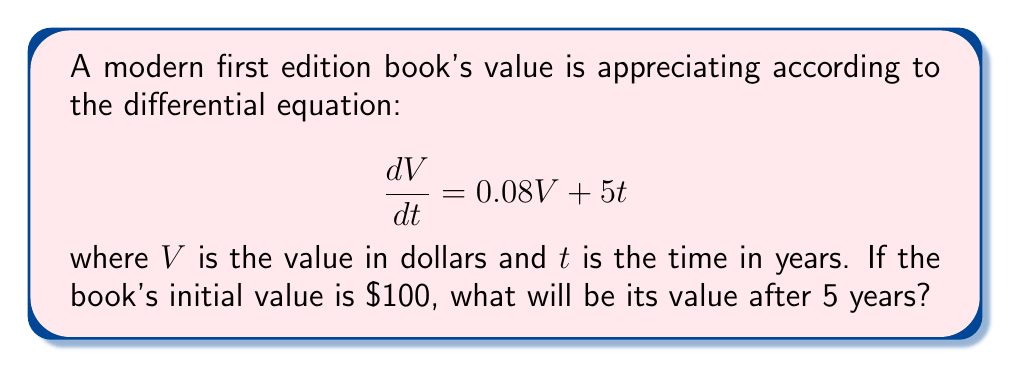Solve this math problem. To solve this first-order linear differential equation, we'll use the integrating factor method:

1) The equation is in the form $\frac{dV}{dt} + P(t)V = Q(t)$ where $P(t) = -0.08$ and $Q(t) = 5t$.

2) The integrating factor is $\mu(t) = e^{\int P(t) dt} = e^{-0.08t}$.

3) Multiply both sides of the equation by $\mu(t)$:

   $e^{-0.08t}\frac{dV}{dt} + 0.08e^{-0.08t}V = 5te^{-0.08t}$

4) The left side is now the derivative of $e^{-0.08t}V$. Rewrite the equation:

   $\frac{d}{dt}(e^{-0.08t}V) = 5te^{-0.08t}$

5) Integrate both sides:

   $e^{-0.08t}V = \int 5te^{-0.08t}dt$

6) Solve the integral on the right side using integration by parts:

   $e^{-0.08t}V = -62.5te^{-0.08t} - 781.25e^{-0.08t} + C$

7) Solve for $V$:

   $V = -62.5t - 781.25 + Ce^{0.08t}$

8) Use the initial condition $V(0) = 100$ to find $C$:

   $100 = -781.25 + C$
   $C = 881.25$

9) The general solution is:

   $V(t) = -62.5t - 781.25 + 881.25e^{0.08t}$

10) Evaluate at $t = 5$:

    $V(5) = -62.5(5) - 781.25 + 881.25e^{0.08(5)}$
          $= -312.5 - 781.25 + 881.25e^{0.4}$
          $\approx 214.76$
Answer: The value of the book after 5 years will be approximately $214.76. 